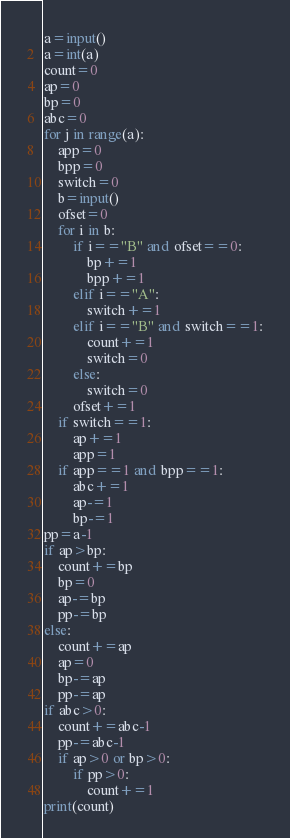Convert code to text. <code><loc_0><loc_0><loc_500><loc_500><_Python_>a=input()
a=int(a)
count=0
ap=0
bp=0
abc=0
for j in range(a):
    app=0
    bpp=0
    switch=0
    b=input()
    ofset=0
    for i in b:
        if i=="B" and ofset==0:
            bp+=1
            bpp+=1
        elif i=="A":
            switch+=1
        elif i=="B" and switch==1:
            count+=1
            switch=0
        else:
            switch=0
        ofset+=1
    if switch==1:
        ap+=1
        app=1
    if app==1 and bpp==1:
        abc+=1
        ap-=1
        bp-=1
pp=a-1
if ap>bp:
    count+=bp
    bp=0
    ap-=bp
    pp-=bp
else:
    count+=ap
    ap=0
    bp-=ap
    pp-=ap
if abc>0:
    count+=abc-1
    pp-=abc-1
    if ap>0 or bp>0:
        if pp>0:
            count+=1
print(count)
</code> 